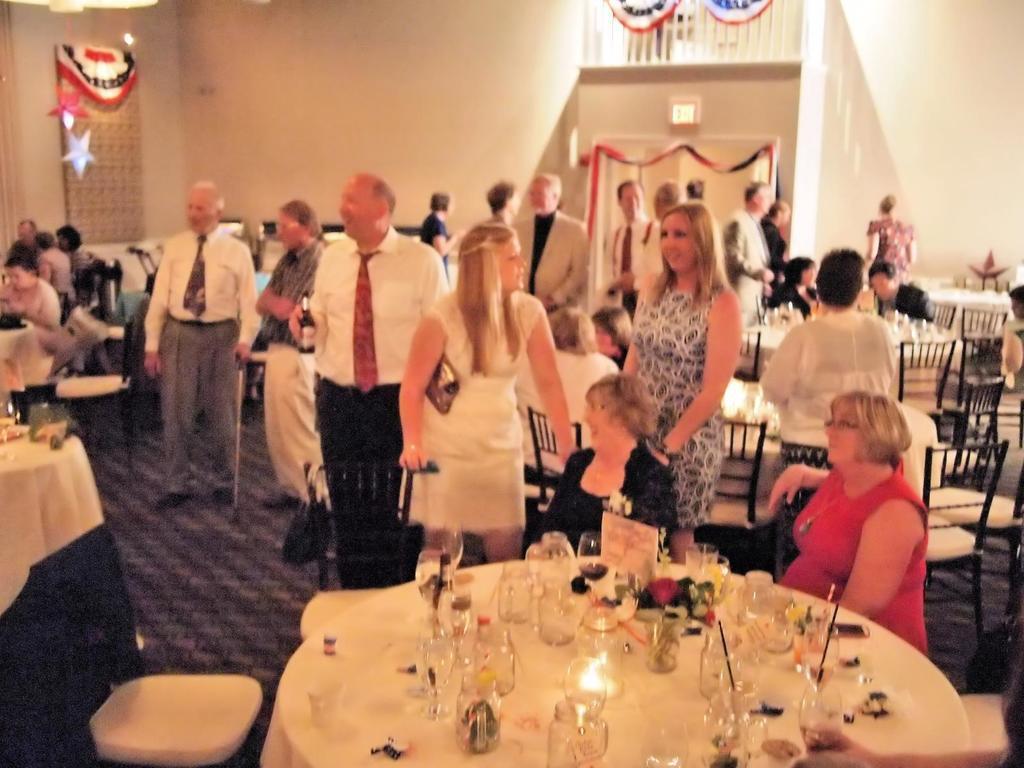Describe this image in one or two sentences. In this image there are a few people sitting on the chairs and few other people standing. In front of them there are tables. On top of it there are glasses, straws and a few other objects. In the background of the image there is a wall. On the left side of the image there are decorative items on the wall. In the center of the image there are decorative items on the metal rods. At the bottom of the image there is a mat on the floor. 